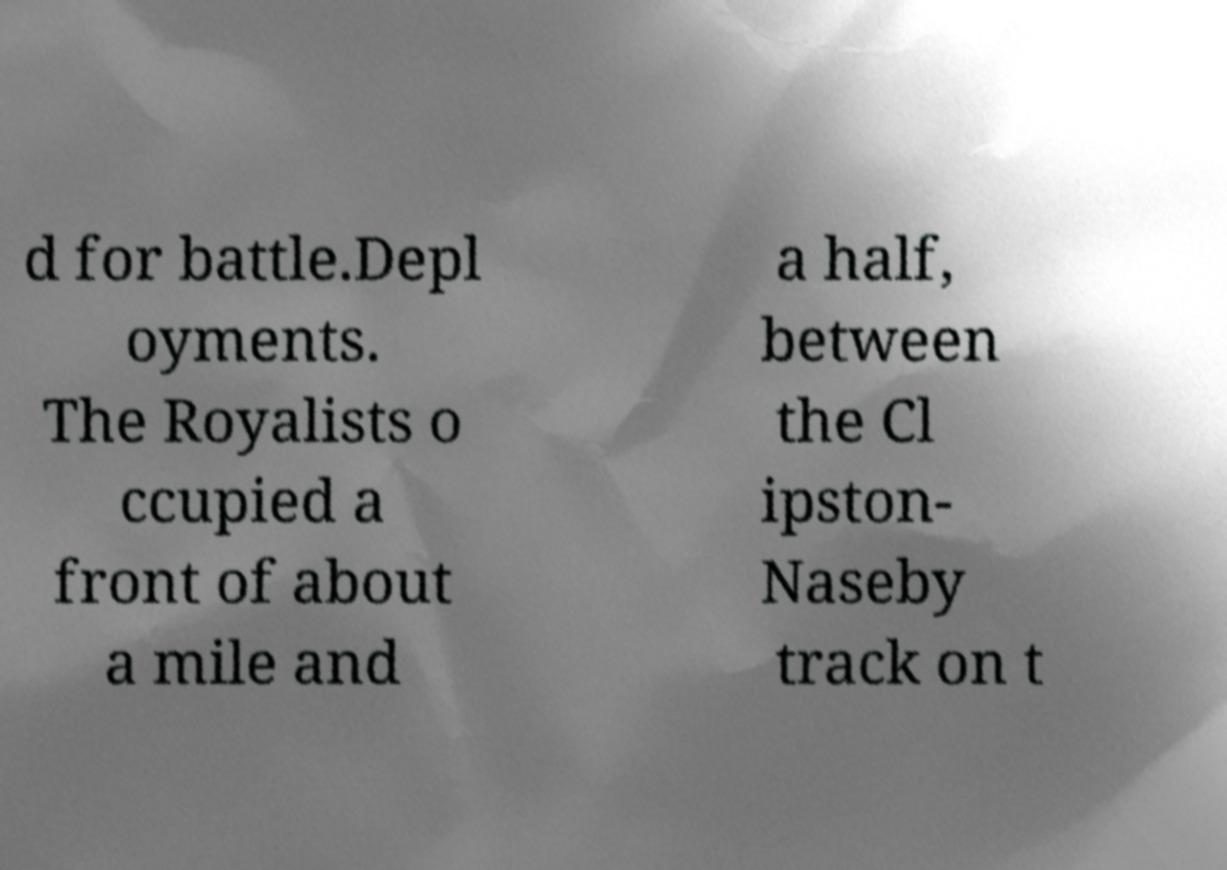Please identify and transcribe the text found in this image. d for battle.Depl oyments. The Royalists o ccupied a front of about a mile and a half, between the Cl ipston- Naseby track on t 